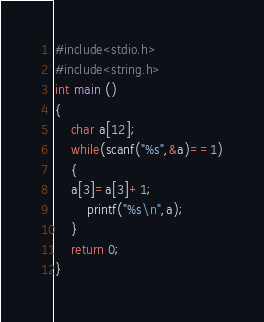Convert code to text. <code><loc_0><loc_0><loc_500><loc_500><_C_>#include<stdio.h>
#include<string.h>
int main ()
{
    char a[12];
    while(scanf("%s",&a)==1)
    {
    a[3]=a[3]+1;
        printf("%s\n",a);
    }
    return 0;
}
</code> 